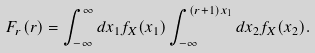<formula> <loc_0><loc_0><loc_500><loc_500>F _ { r } ( r ) = \int _ { - \infty } ^ { \infty } d x _ { 1 } f _ { X } ( x _ { 1 } ) \int _ { - \infty } ^ { ( r + 1 ) x _ { 1 } } d x _ { 2 } f _ { X } ( x _ { 2 } ) .</formula> 